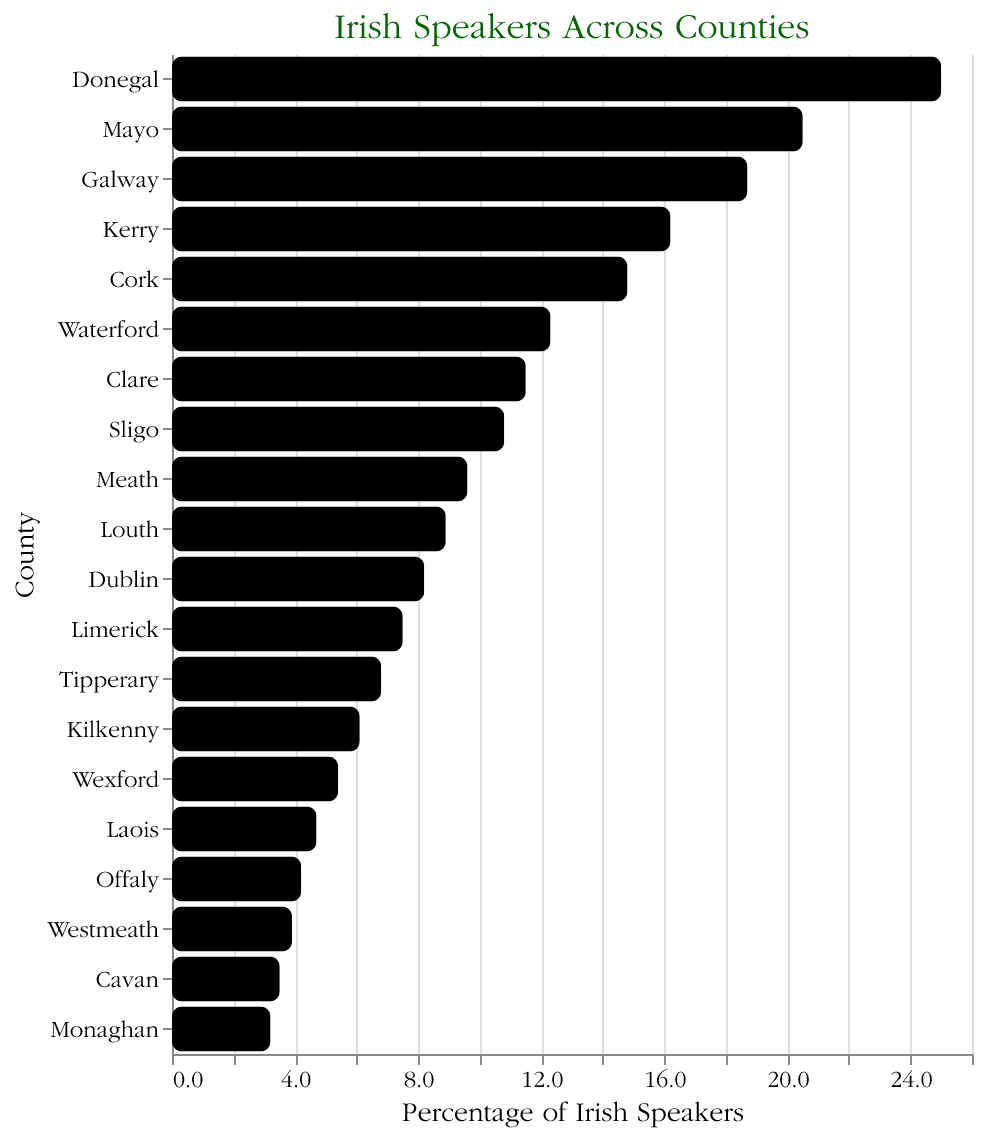Which county has the highest percentage of Irish speakers? The highest bar represents the county with the highest percentage. In this case, Donegal has the tallest bar at 25.0%.
Answer: Donegal What is the percentage of Irish speakers in Dublin? Locate the bar labeled Dublin and check its length along the x-axis. The tooltip shows 8.2%.
Answer: 8.2% Which county has slightly more Irish speakers, Clare or Sligo? Compare the bars for Clare and Sligo. Clare's bar is at 11.5%, and Sligo's bar is at 10.8%. Clare is higher.
Answer: Clare How many counties have an Irish speakers percentage greater than 10%? Count the bars with lengths more than 10% on the x-axis. Donegal, Mayo, Galway, Kerry, Cork, Waterford, Clare, and Sligo are all over 10%.
Answer: 8 What is the total percentage of Irish speakers for the top three counties? Add the percentages for Donegal (25.0%), Mayo (20.5%), and Galway (18.7%). 25.0 + 20.5 + 18.7 = 64.2%.
Answer: 64.2% What is the average percentage of Irish speakers for Cork, Wexford, and Laois? Summing the percentages for Cork (14.8%), Wexford (5.4%), and Laois (4.7%) gives 14.8 + 5.4 + 4.7 = 24.9. Divide by 3 to get the average: 24.9 / 3 ≈ 8.3%.
Answer: 8.3% Which county among Westmeath, Cavan, and Monaghan has the lowest percentage of Irish speakers? Compare the bars for Westmeath, Cavan, and Monaghan. Monaghan has the shortest bar at 3.2%.
Answer: Monaghan What is the median percentage of Irish speakers across all counties? Ordering all percentages: [3.2, 3.5, 3.9, 4.2, 4.7, 5.4, 6.1, 6.8, 7.5, 8.2, 8.9, 9.6, 10.8, 11.5, 12.3, 14.8, 16.2, 18.7, 20.5, 25.0]. The median is the middle value: 8.2%.
Answer: 8.2% What is the difference in the percentage of Irish speakers between the highest (Donegal) and lowest (Monaghan) counties? Subtract the percentage of Monaghan from Donegal: 25.0% - 3.2% = 21.8%.
Answer: 21.8% Which county has the greatest decrease in percentage compared to the previous county in the list? Look for the largest gap between successive bars. Between Mayo (20.5%) and Galway (18.7%), the difference is 20.5 - 18.7 = 1.8%.
Answer: Mayo to Galway 